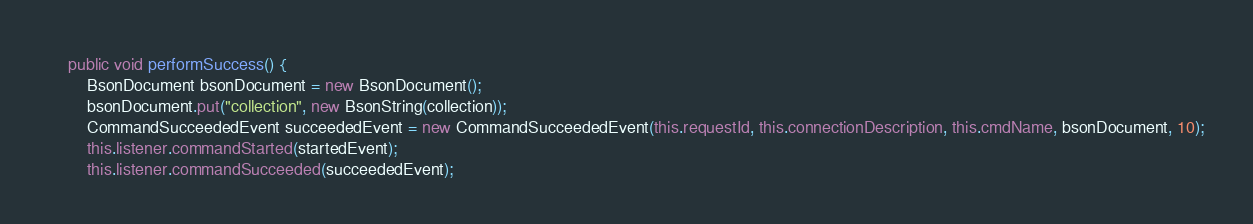Convert code to text. <code><loc_0><loc_0><loc_500><loc_500><_Java_>    public void performSuccess() {
        BsonDocument bsonDocument = new BsonDocument();
        bsonDocument.put("collection", new BsonString(collection));
        CommandSucceededEvent succeededEvent = new CommandSucceededEvent(this.requestId, this.connectionDescription, this.cmdName, bsonDocument, 10);
        this.listener.commandStarted(startedEvent);
        this.listener.commandSucceeded(succeededEvent);</code> 